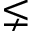<formula> <loc_0><loc_0><loc_500><loc_500>\lneq</formula> 